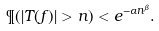<formula> <loc_0><loc_0><loc_500><loc_500>\P ( | T ( f ) | > n ) < e ^ { - \alpha n ^ { \beta } } .</formula> 